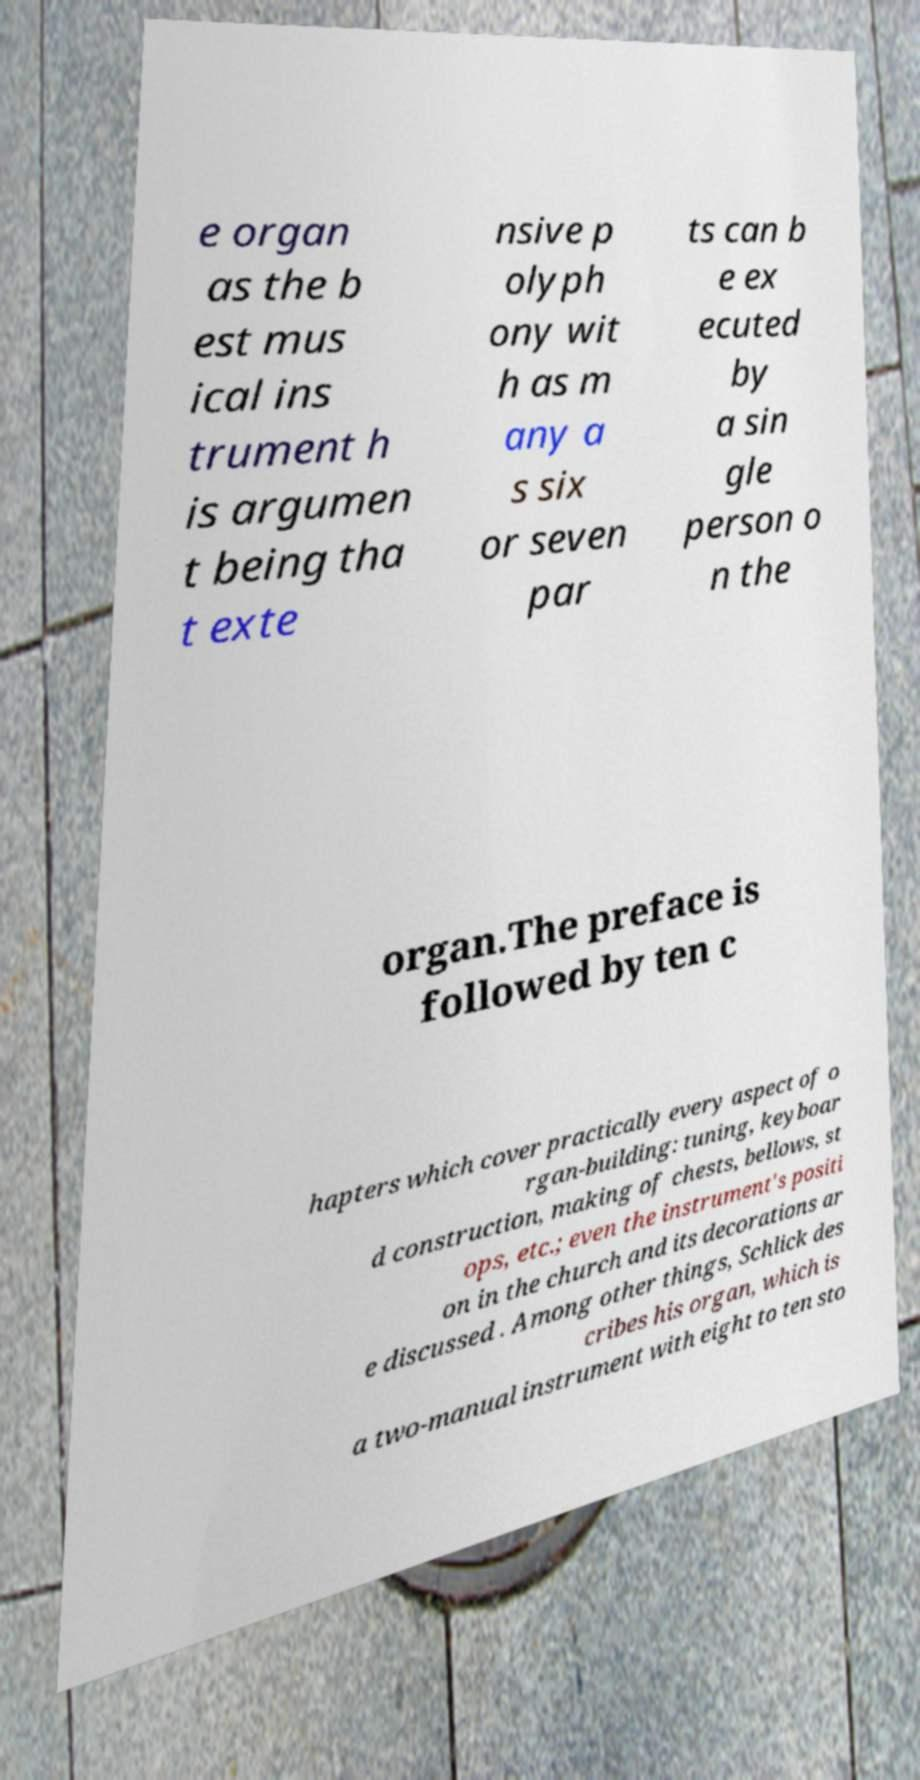Please read and relay the text visible in this image. What does it say? e organ as the b est mus ical ins trument h is argumen t being tha t exte nsive p olyph ony wit h as m any a s six or seven par ts can b e ex ecuted by a sin gle person o n the organ.The preface is followed by ten c hapters which cover practically every aspect of o rgan-building: tuning, keyboar d construction, making of chests, bellows, st ops, etc.; even the instrument's positi on in the church and its decorations ar e discussed . Among other things, Schlick des cribes his organ, which is a two-manual instrument with eight to ten sto 